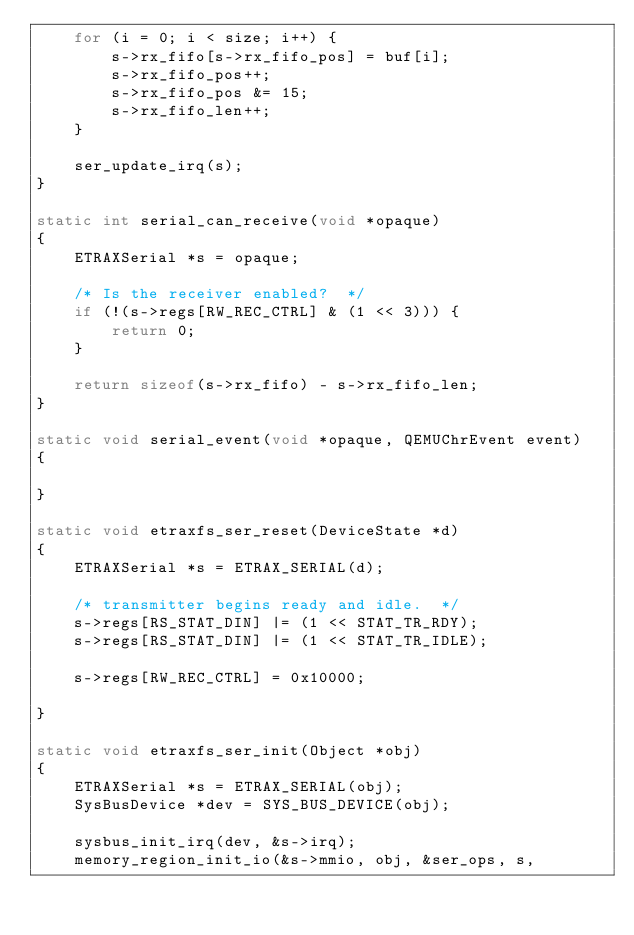Convert code to text. <code><loc_0><loc_0><loc_500><loc_500><_C_>    for (i = 0; i < size; i++) { 
        s->rx_fifo[s->rx_fifo_pos] = buf[i];
        s->rx_fifo_pos++;
        s->rx_fifo_pos &= 15;
        s->rx_fifo_len++;
    }

    ser_update_irq(s);
}

static int serial_can_receive(void *opaque)
{
    ETRAXSerial *s = opaque;

    /* Is the receiver enabled?  */
    if (!(s->regs[RW_REC_CTRL] & (1 << 3))) {
        return 0;
    }

    return sizeof(s->rx_fifo) - s->rx_fifo_len;
}

static void serial_event(void *opaque, QEMUChrEvent event)
{

}

static void etraxfs_ser_reset(DeviceState *d)
{
    ETRAXSerial *s = ETRAX_SERIAL(d);

    /* transmitter begins ready and idle.  */
    s->regs[RS_STAT_DIN] |= (1 << STAT_TR_RDY);
    s->regs[RS_STAT_DIN] |= (1 << STAT_TR_IDLE);

    s->regs[RW_REC_CTRL] = 0x10000;

}

static void etraxfs_ser_init(Object *obj)
{
    ETRAXSerial *s = ETRAX_SERIAL(obj);
    SysBusDevice *dev = SYS_BUS_DEVICE(obj);

    sysbus_init_irq(dev, &s->irq);
    memory_region_init_io(&s->mmio, obj, &ser_ops, s,</code> 